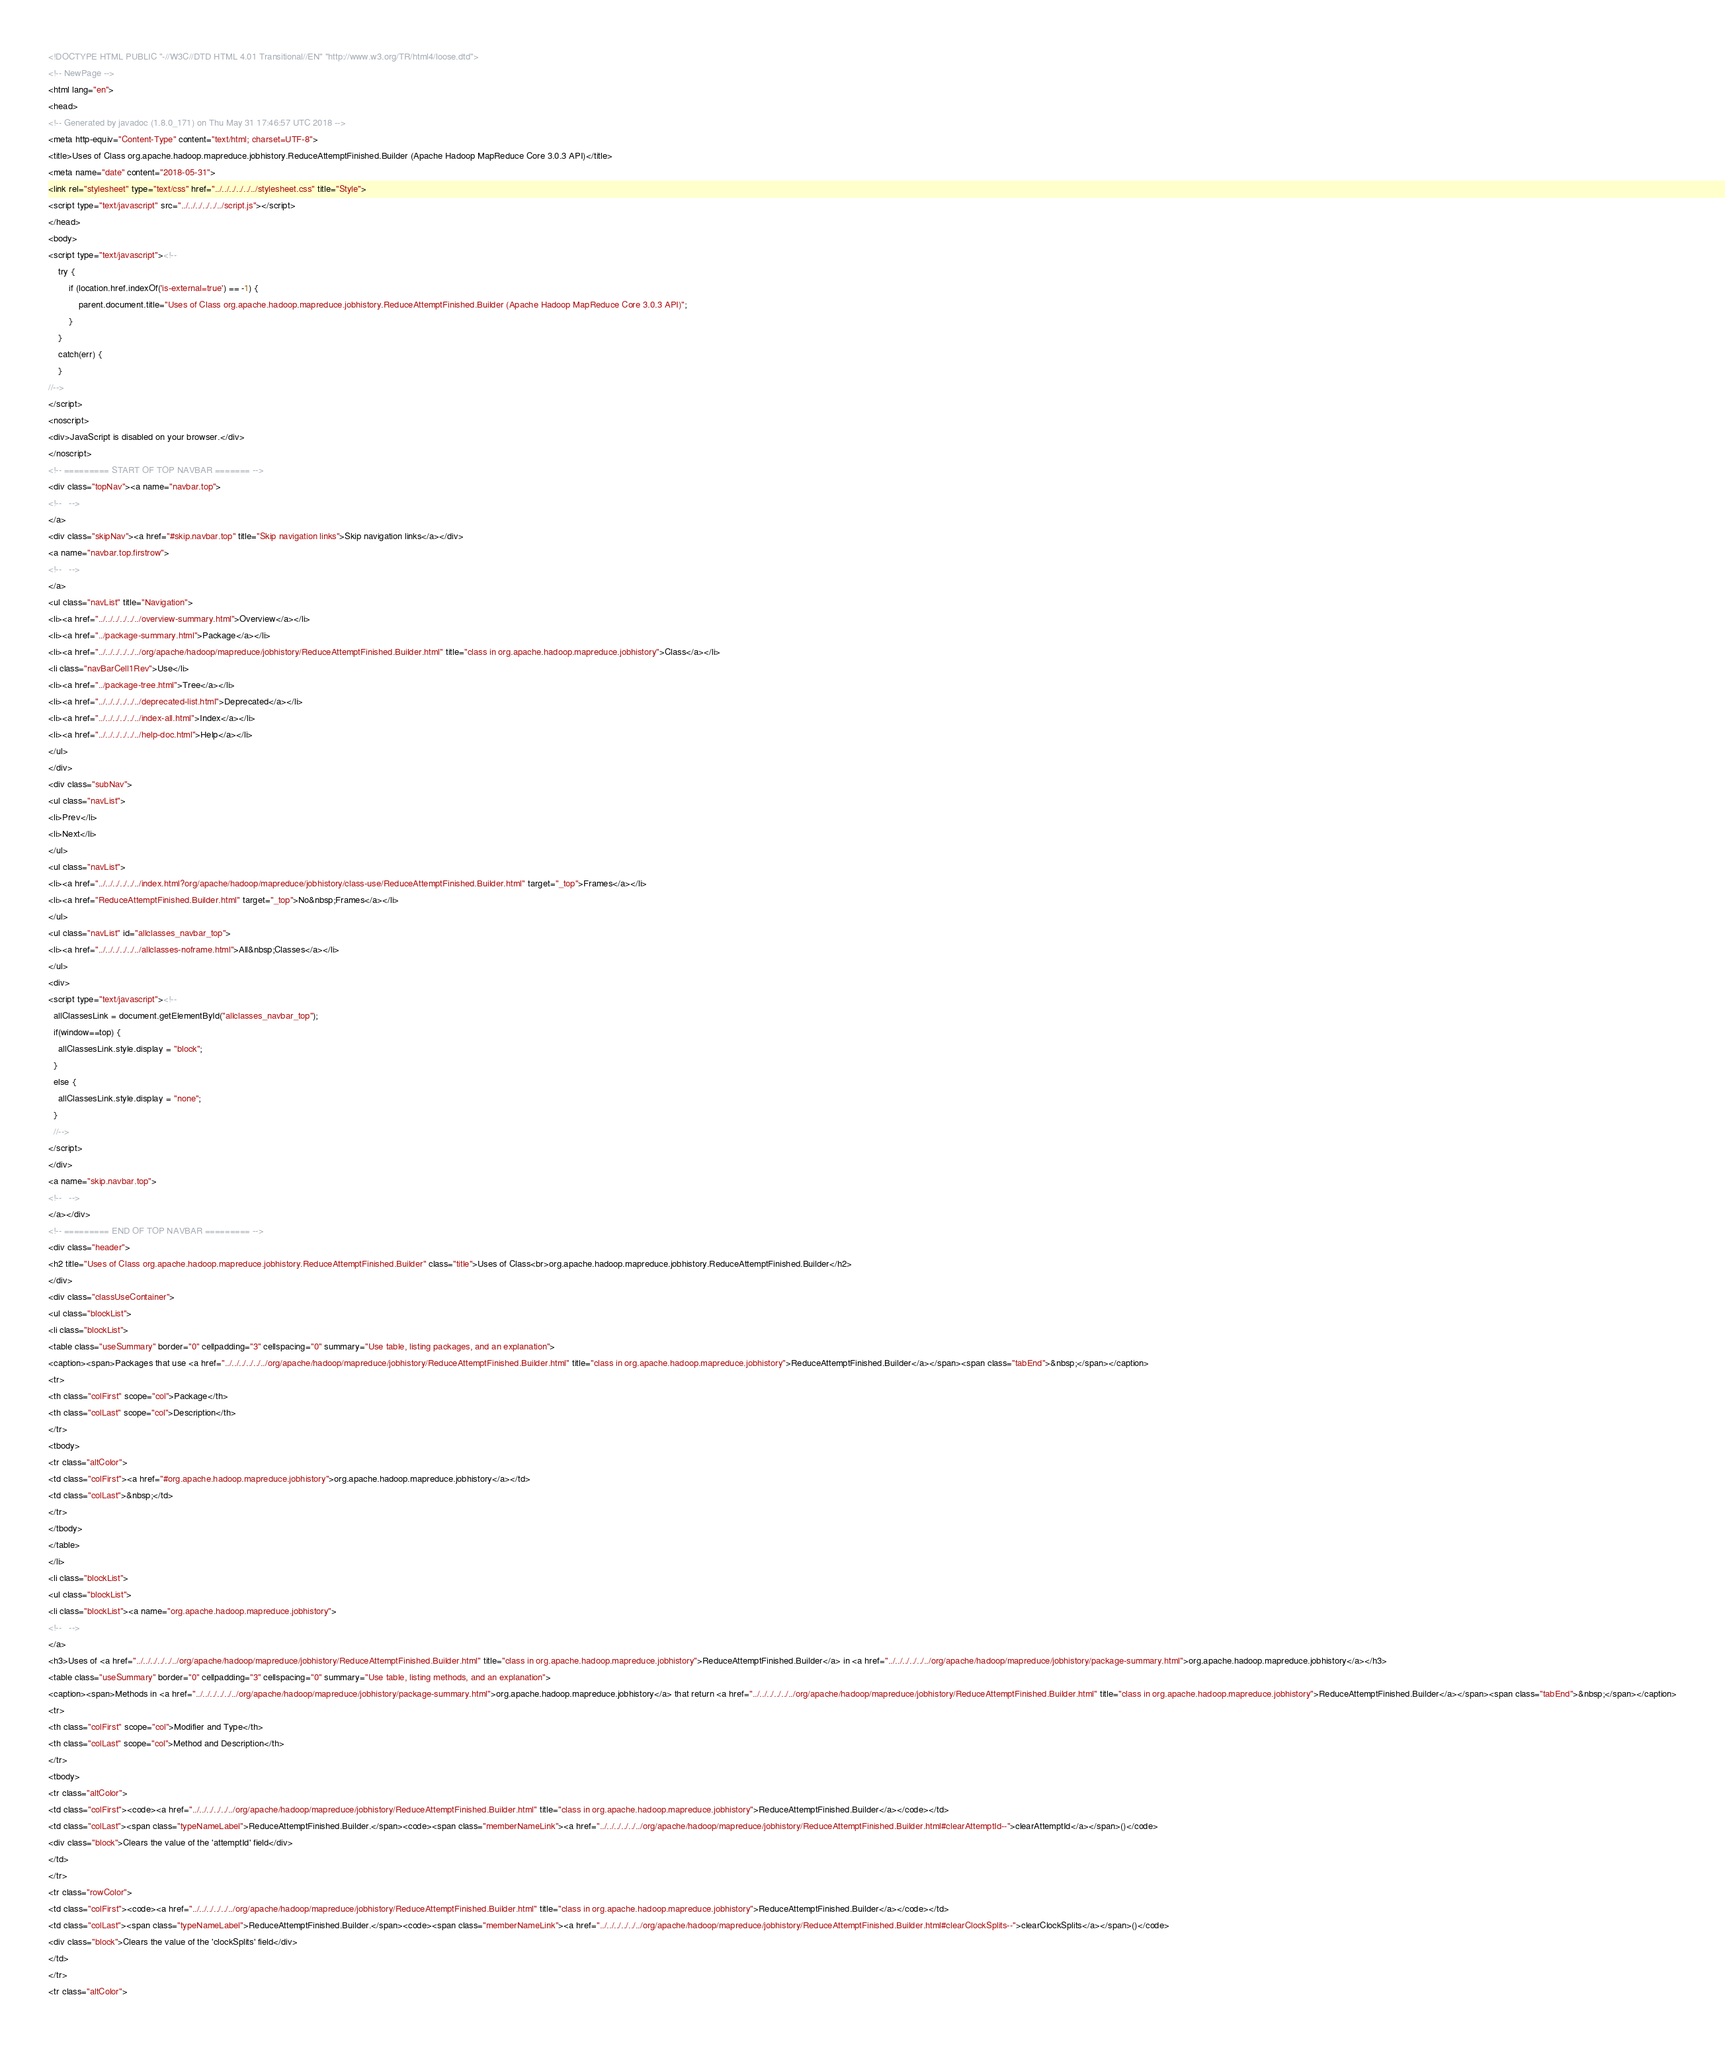<code> <loc_0><loc_0><loc_500><loc_500><_HTML_><!DOCTYPE HTML PUBLIC "-//W3C//DTD HTML 4.01 Transitional//EN" "http://www.w3.org/TR/html4/loose.dtd">
<!-- NewPage -->
<html lang="en">
<head>
<!-- Generated by javadoc (1.8.0_171) on Thu May 31 17:46:57 UTC 2018 -->
<meta http-equiv="Content-Type" content="text/html; charset=UTF-8">
<title>Uses of Class org.apache.hadoop.mapreduce.jobhistory.ReduceAttemptFinished.Builder (Apache Hadoop MapReduce Core 3.0.3 API)</title>
<meta name="date" content="2018-05-31">
<link rel="stylesheet" type="text/css" href="../../../../../../stylesheet.css" title="Style">
<script type="text/javascript" src="../../../../../../script.js"></script>
</head>
<body>
<script type="text/javascript"><!--
    try {
        if (location.href.indexOf('is-external=true') == -1) {
            parent.document.title="Uses of Class org.apache.hadoop.mapreduce.jobhistory.ReduceAttemptFinished.Builder (Apache Hadoop MapReduce Core 3.0.3 API)";
        }
    }
    catch(err) {
    }
//-->
</script>
<noscript>
<div>JavaScript is disabled on your browser.</div>
</noscript>
<!-- ========= START OF TOP NAVBAR ======= -->
<div class="topNav"><a name="navbar.top">
<!--   -->
</a>
<div class="skipNav"><a href="#skip.navbar.top" title="Skip navigation links">Skip navigation links</a></div>
<a name="navbar.top.firstrow">
<!--   -->
</a>
<ul class="navList" title="Navigation">
<li><a href="../../../../../../overview-summary.html">Overview</a></li>
<li><a href="../package-summary.html">Package</a></li>
<li><a href="../../../../../../org/apache/hadoop/mapreduce/jobhistory/ReduceAttemptFinished.Builder.html" title="class in org.apache.hadoop.mapreduce.jobhistory">Class</a></li>
<li class="navBarCell1Rev">Use</li>
<li><a href="../package-tree.html">Tree</a></li>
<li><a href="../../../../../../deprecated-list.html">Deprecated</a></li>
<li><a href="../../../../../../index-all.html">Index</a></li>
<li><a href="../../../../../../help-doc.html">Help</a></li>
</ul>
</div>
<div class="subNav">
<ul class="navList">
<li>Prev</li>
<li>Next</li>
</ul>
<ul class="navList">
<li><a href="../../../../../../index.html?org/apache/hadoop/mapreduce/jobhistory/class-use/ReduceAttemptFinished.Builder.html" target="_top">Frames</a></li>
<li><a href="ReduceAttemptFinished.Builder.html" target="_top">No&nbsp;Frames</a></li>
</ul>
<ul class="navList" id="allclasses_navbar_top">
<li><a href="../../../../../../allclasses-noframe.html">All&nbsp;Classes</a></li>
</ul>
<div>
<script type="text/javascript"><!--
  allClassesLink = document.getElementById("allclasses_navbar_top");
  if(window==top) {
    allClassesLink.style.display = "block";
  }
  else {
    allClassesLink.style.display = "none";
  }
  //-->
</script>
</div>
<a name="skip.navbar.top">
<!--   -->
</a></div>
<!-- ========= END OF TOP NAVBAR ========= -->
<div class="header">
<h2 title="Uses of Class org.apache.hadoop.mapreduce.jobhistory.ReduceAttemptFinished.Builder" class="title">Uses of Class<br>org.apache.hadoop.mapreduce.jobhistory.ReduceAttemptFinished.Builder</h2>
</div>
<div class="classUseContainer">
<ul class="blockList">
<li class="blockList">
<table class="useSummary" border="0" cellpadding="3" cellspacing="0" summary="Use table, listing packages, and an explanation">
<caption><span>Packages that use <a href="../../../../../../org/apache/hadoop/mapreduce/jobhistory/ReduceAttemptFinished.Builder.html" title="class in org.apache.hadoop.mapreduce.jobhistory">ReduceAttemptFinished.Builder</a></span><span class="tabEnd">&nbsp;</span></caption>
<tr>
<th class="colFirst" scope="col">Package</th>
<th class="colLast" scope="col">Description</th>
</tr>
<tbody>
<tr class="altColor">
<td class="colFirst"><a href="#org.apache.hadoop.mapreduce.jobhistory">org.apache.hadoop.mapreduce.jobhistory</a></td>
<td class="colLast">&nbsp;</td>
</tr>
</tbody>
</table>
</li>
<li class="blockList">
<ul class="blockList">
<li class="blockList"><a name="org.apache.hadoop.mapreduce.jobhistory">
<!--   -->
</a>
<h3>Uses of <a href="../../../../../../org/apache/hadoop/mapreduce/jobhistory/ReduceAttemptFinished.Builder.html" title="class in org.apache.hadoop.mapreduce.jobhistory">ReduceAttemptFinished.Builder</a> in <a href="../../../../../../org/apache/hadoop/mapreduce/jobhistory/package-summary.html">org.apache.hadoop.mapreduce.jobhistory</a></h3>
<table class="useSummary" border="0" cellpadding="3" cellspacing="0" summary="Use table, listing methods, and an explanation">
<caption><span>Methods in <a href="../../../../../../org/apache/hadoop/mapreduce/jobhistory/package-summary.html">org.apache.hadoop.mapreduce.jobhistory</a> that return <a href="../../../../../../org/apache/hadoop/mapreduce/jobhistory/ReduceAttemptFinished.Builder.html" title="class in org.apache.hadoop.mapreduce.jobhistory">ReduceAttemptFinished.Builder</a></span><span class="tabEnd">&nbsp;</span></caption>
<tr>
<th class="colFirst" scope="col">Modifier and Type</th>
<th class="colLast" scope="col">Method and Description</th>
</tr>
<tbody>
<tr class="altColor">
<td class="colFirst"><code><a href="../../../../../../org/apache/hadoop/mapreduce/jobhistory/ReduceAttemptFinished.Builder.html" title="class in org.apache.hadoop.mapreduce.jobhistory">ReduceAttemptFinished.Builder</a></code></td>
<td class="colLast"><span class="typeNameLabel">ReduceAttemptFinished.Builder.</span><code><span class="memberNameLink"><a href="../../../../../../org/apache/hadoop/mapreduce/jobhistory/ReduceAttemptFinished.Builder.html#clearAttemptId--">clearAttemptId</a></span>()</code>
<div class="block">Clears the value of the 'attemptId' field</div>
</td>
</tr>
<tr class="rowColor">
<td class="colFirst"><code><a href="../../../../../../org/apache/hadoop/mapreduce/jobhistory/ReduceAttemptFinished.Builder.html" title="class in org.apache.hadoop.mapreduce.jobhistory">ReduceAttemptFinished.Builder</a></code></td>
<td class="colLast"><span class="typeNameLabel">ReduceAttemptFinished.Builder.</span><code><span class="memberNameLink"><a href="../../../../../../org/apache/hadoop/mapreduce/jobhistory/ReduceAttemptFinished.Builder.html#clearClockSplits--">clearClockSplits</a></span>()</code>
<div class="block">Clears the value of the 'clockSplits' field</div>
</td>
</tr>
<tr class="altColor"></code> 